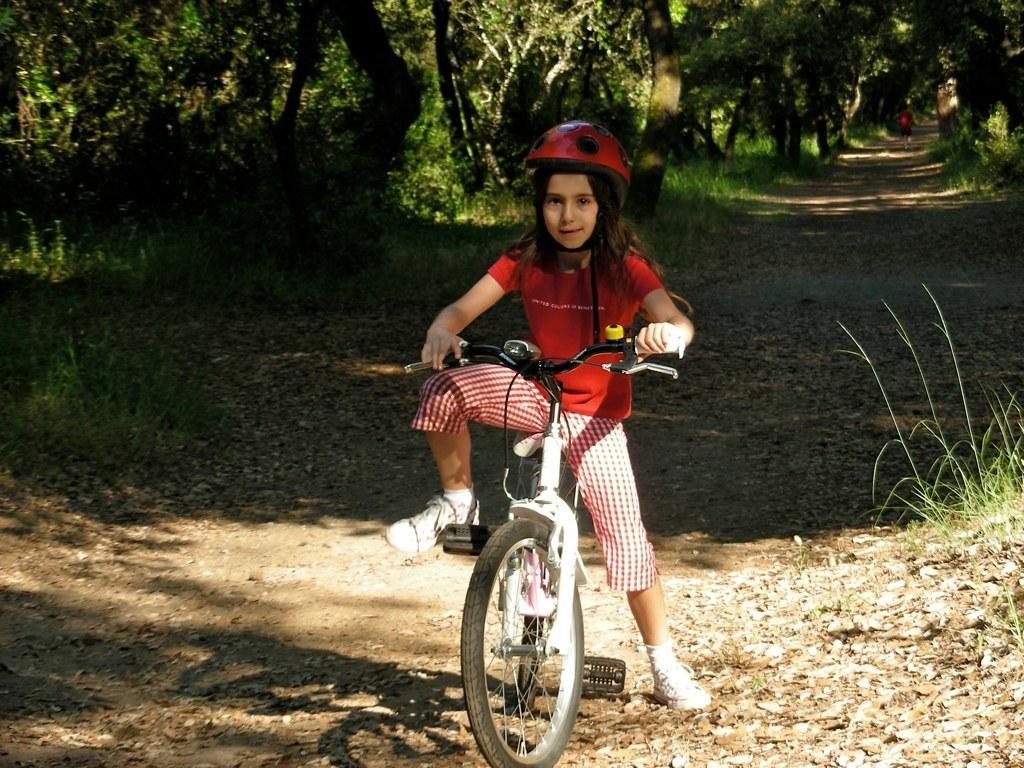What is the kid wearing on their head in the image? The kid is wearing a helmet. What color is the kid's t-shirt in the image? The kid is wearing a red t-shirt. What is the kid sitting on in the image? The kid is sitting on a bicycle. What type of vegetation can be seen in the distance in the image? There are trees and grass in the distance. What is happening in the distance in the image? A person is walking in the distance. How many calendars are hanging on the trees in the image? There are no calendars present in the image; it features a kid wearing a helmet and a red t-shirt, sitting on a bicycle, with trees, grass, and a person walking in the distance. 